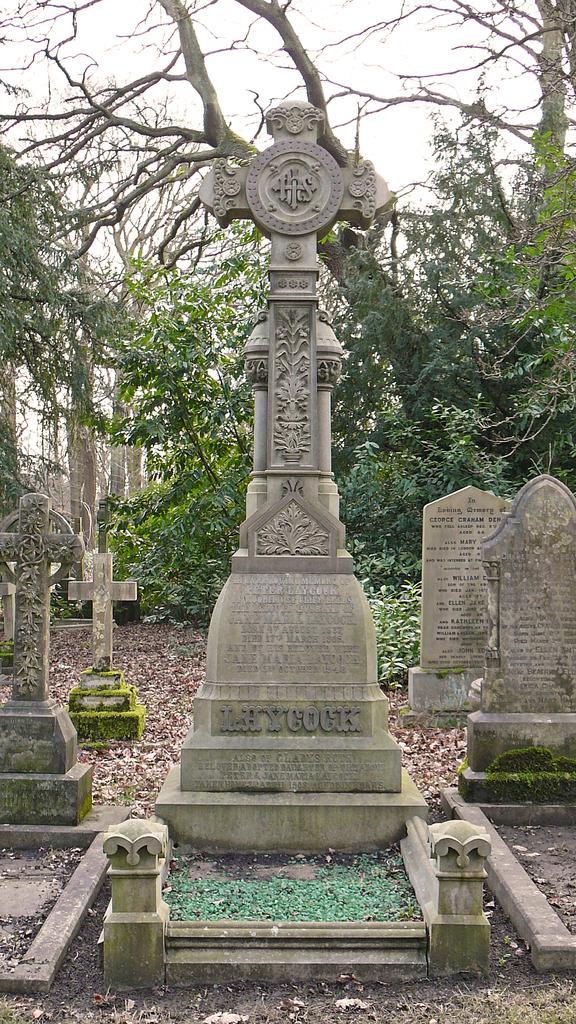Describe this image in one or two sentences. In this image I can see the cemetery. In the background I can see many trees and the sky. 